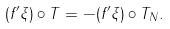<formula> <loc_0><loc_0><loc_500><loc_500>( f ^ { \prime } \xi ) \circ T = - ( f ^ { \prime } \xi ) \circ T _ { N } .</formula> 